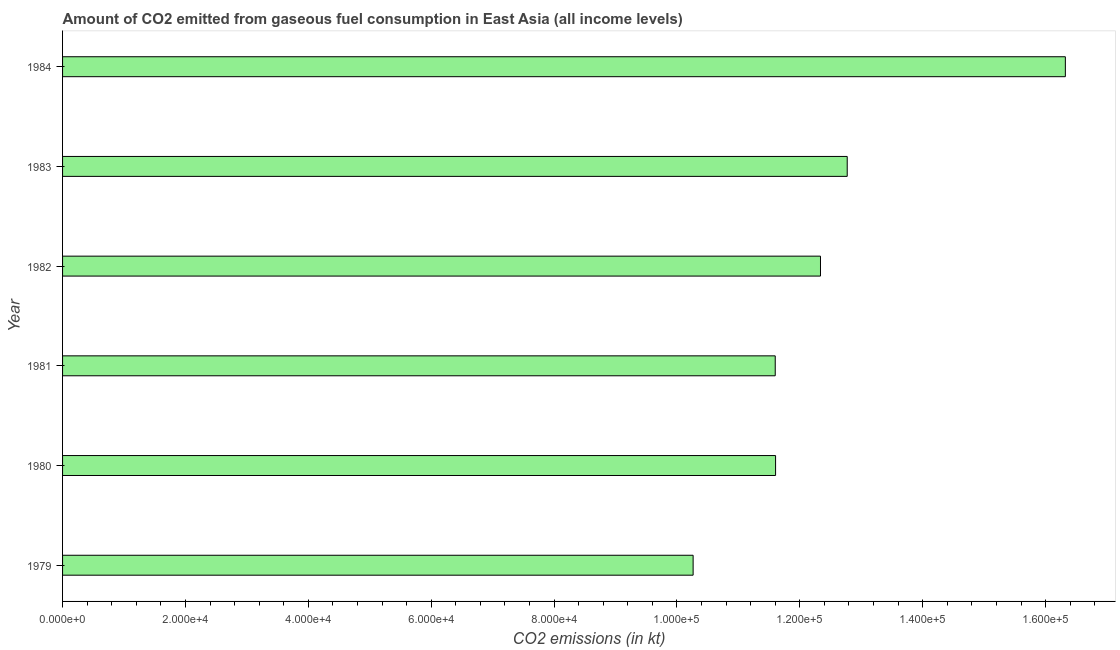What is the title of the graph?
Keep it short and to the point. Amount of CO2 emitted from gaseous fuel consumption in East Asia (all income levels). What is the label or title of the X-axis?
Offer a terse response. CO2 emissions (in kt). What is the label or title of the Y-axis?
Your answer should be very brief. Year. What is the co2 emissions from gaseous fuel consumption in 1984?
Provide a short and direct response. 1.63e+05. Across all years, what is the maximum co2 emissions from gaseous fuel consumption?
Give a very brief answer. 1.63e+05. Across all years, what is the minimum co2 emissions from gaseous fuel consumption?
Offer a terse response. 1.03e+05. In which year was the co2 emissions from gaseous fuel consumption maximum?
Your answer should be compact. 1984. In which year was the co2 emissions from gaseous fuel consumption minimum?
Provide a succinct answer. 1979. What is the sum of the co2 emissions from gaseous fuel consumption?
Your answer should be very brief. 7.49e+05. What is the difference between the co2 emissions from gaseous fuel consumption in 1980 and 1984?
Ensure brevity in your answer.  -4.72e+04. What is the average co2 emissions from gaseous fuel consumption per year?
Keep it short and to the point. 1.25e+05. What is the median co2 emissions from gaseous fuel consumption?
Provide a succinct answer. 1.20e+05. What is the ratio of the co2 emissions from gaseous fuel consumption in 1981 to that in 1983?
Give a very brief answer. 0.91. Is the co2 emissions from gaseous fuel consumption in 1980 less than that in 1983?
Your response must be concise. Yes. What is the difference between the highest and the second highest co2 emissions from gaseous fuel consumption?
Give a very brief answer. 3.55e+04. What is the difference between the highest and the lowest co2 emissions from gaseous fuel consumption?
Your response must be concise. 6.06e+04. How many bars are there?
Your answer should be very brief. 6. What is the difference between two consecutive major ticks on the X-axis?
Provide a short and direct response. 2.00e+04. Are the values on the major ticks of X-axis written in scientific E-notation?
Ensure brevity in your answer.  Yes. What is the CO2 emissions (in kt) in 1979?
Provide a short and direct response. 1.03e+05. What is the CO2 emissions (in kt) in 1980?
Make the answer very short. 1.16e+05. What is the CO2 emissions (in kt) of 1981?
Provide a short and direct response. 1.16e+05. What is the CO2 emissions (in kt) in 1982?
Give a very brief answer. 1.23e+05. What is the CO2 emissions (in kt) in 1983?
Your answer should be very brief. 1.28e+05. What is the CO2 emissions (in kt) of 1984?
Make the answer very short. 1.63e+05. What is the difference between the CO2 emissions (in kt) in 1979 and 1980?
Make the answer very short. -1.34e+04. What is the difference between the CO2 emissions (in kt) in 1979 and 1981?
Your answer should be compact. -1.34e+04. What is the difference between the CO2 emissions (in kt) in 1979 and 1982?
Your answer should be compact. -2.07e+04. What is the difference between the CO2 emissions (in kt) in 1979 and 1983?
Your answer should be very brief. -2.51e+04. What is the difference between the CO2 emissions (in kt) in 1979 and 1984?
Provide a succinct answer. -6.06e+04. What is the difference between the CO2 emissions (in kt) in 1980 and 1981?
Your answer should be very brief. 55.92. What is the difference between the CO2 emissions (in kt) in 1980 and 1982?
Make the answer very short. -7311.1. What is the difference between the CO2 emissions (in kt) in 1980 and 1983?
Offer a terse response. -1.17e+04. What is the difference between the CO2 emissions (in kt) in 1980 and 1984?
Offer a very short reply. -4.72e+04. What is the difference between the CO2 emissions (in kt) in 1981 and 1982?
Ensure brevity in your answer.  -7367.03. What is the difference between the CO2 emissions (in kt) in 1981 and 1983?
Provide a short and direct response. -1.17e+04. What is the difference between the CO2 emissions (in kt) in 1981 and 1984?
Provide a short and direct response. -4.72e+04. What is the difference between the CO2 emissions (in kt) in 1982 and 1983?
Your response must be concise. -4351.22. What is the difference between the CO2 emissions (in kt) in 1982 and 1984?
Make the answer very short. -3.99e+04. What is the difference between the CO2 emissions (in kt) in 1983 and 1984?
Your answer should be very brief. -3.55e+04. What is the ratio of the CO2 emissions (in kt) in 1979 to that in 1980?
Give a very brief answer. 0.88. What is the ratio of the CO2 emissions (in kt) in 1979 to that in 1981?
Your answer should be compact. 0.89. What is the ratio of the CO2 emissions (in kt) in 1979 to that in 1982?
Give a very brief answer. 0.83. What is the ratio of the CO2 emissions (in kt) in 1979 to that in 1983?
Keep it short and to the point. 0.8. What is the ratio of the CO2 emissions (in kt) in 1979 to that in 1984?
Make the answer very short. 0.63. What is the ratio of the CO2 emissions (in kt) in 1980 to that in 1982?
Offer a terse response. 0.94. What is the ratio of the CO2 emissions (in kt) in 1980 to that in 1983?
Your answer should be very brief. 0.91. What is the ratio of the CO2 emissions (in kt) in 1980 to that in 1984?
Offer a very short reply. 0.71. What is the ratio of the CO2 emissions (in kt) in 1981 to that in 1982?
Give a very brief answer. 0.94. What is the ratio of the CO2 emissions (in kt) in 1981 to that in 1983?
Your answer should be compact. 0.91. What is the ratio of the CO2 emissions (in kt) in 1981 to that in 1984?
Offer a very short reply. 0.71. What is the ratio of the CO2 emissions (in kt) in 1982 to that in 1984?
Your answer should be very brief. 0.76. What is the ratio of the CO2 emissions (in kt) in 1983 to that in 1984?
Your response must be concise. 0.78. 